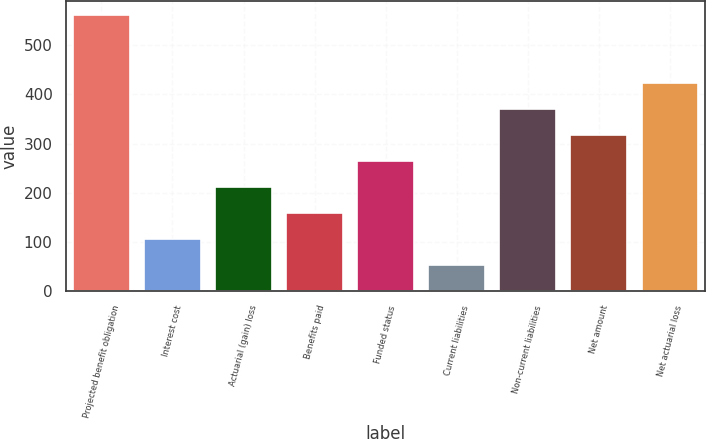Convert chart. <chart><loc_0><loc_0><loc_500><loc_500><bar_chart><fcel>Projected benefit obligation<fcel>Interest cost<fcel>Actuarial (gain) loss<fcel>Benefits paid<fcel>Funded status<fcel>Current liabilities<fcel>Non-current liabilities<fcel>Net amount<fcel>Net actuarial loss<nl><fcel>561.24<fcel>106.28<fcel>211.76<fcel>159.02<fcel>264.5<fcel>53.54<fcel>369.98<fcel>317.24<fcel>422.72<nl></chart> 